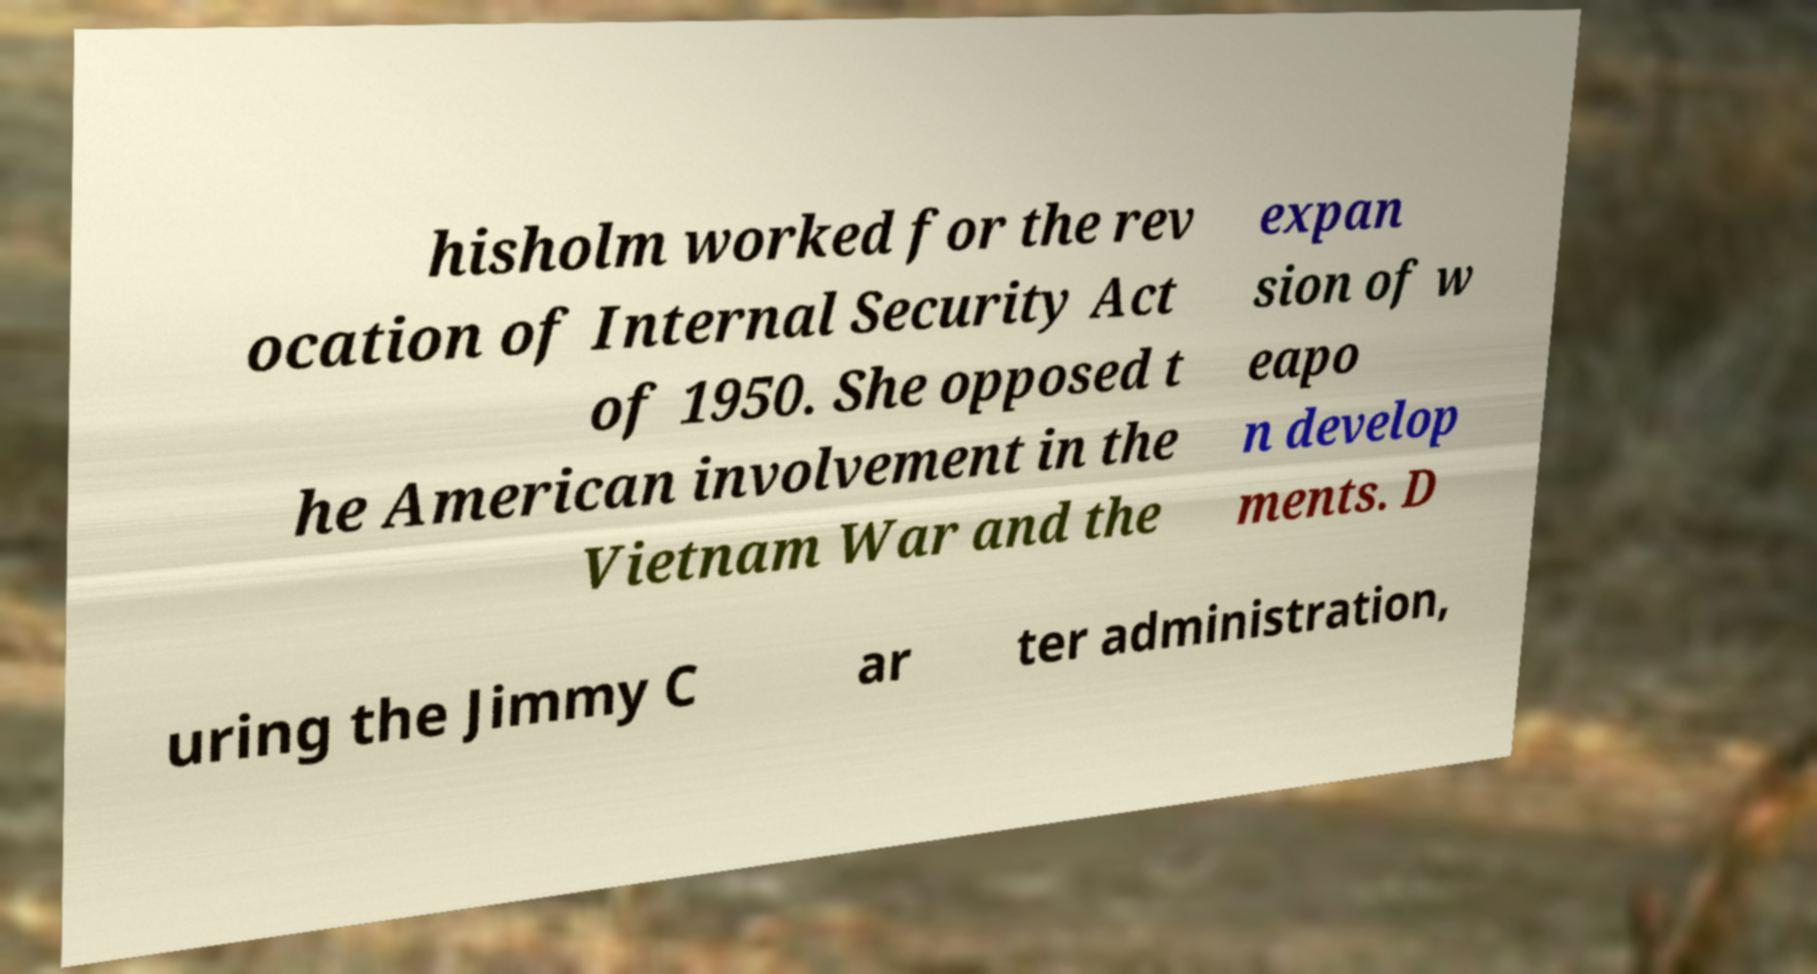Could you assist in decoding the text presented in this image and type it out clearly? hisholm worked for the rev ocation of Internal Security Act of 1950. She opposed t he American involvement in the Vietnam War and the expan sion of w eapo n develop ments. D uring the Jimmy C ar ter administration, 